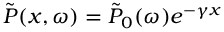<formula> <loc_0><loc_0><loc_500><loc_500>\tilde { P } ( x , \omega ) = \tilde { P } _ { 0 } ( \omega ) e ^ { - \gamma x }</formula> 